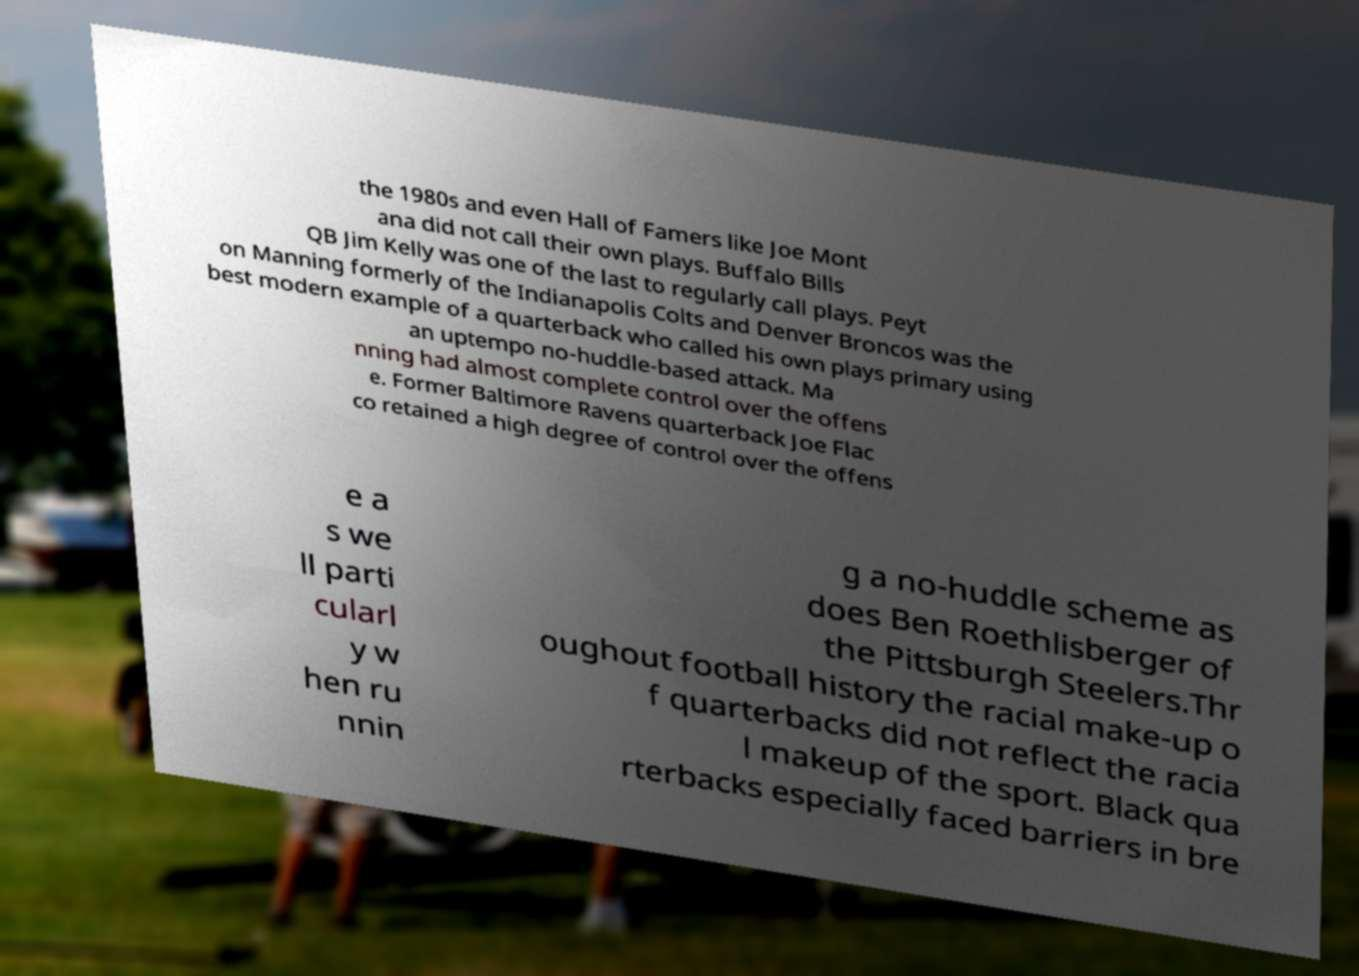Can you accurately transcribe the text from the provided image for me? the 1980s and even Hall of Famers like Joe Mont ana did not call their own plays. Buffalo Bills QB Jim Kelly was one of the last to regularly call plays. Peyt on Manning formerly of the Indianapolis Colts and Denver Broncos was the best modern example of a quarterback who called his own plays primary using an uptempo no-huddle-based attack. Ma nning had almost complete control over the offens e. Former Baltimore Ravens quarterback Joe Flac co retained a high degree of control over the offens e a s we ll parti cularl y w hen ru nnin g a no-huddle scheme as does Ben Roethlisberger of the Pittsburgh Steelers.Thr oughout football history the racial make-up o f quarterbacks did not reflect the racia l makeup of the sport. Black qua rterbacks especially faced barriers in bre 